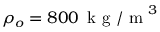<formula> <loc_0><loc_0><loc_500><loc_500>\rho _ { o } = 8 0 0 \, k g / m ^ { 3 }</formula> 